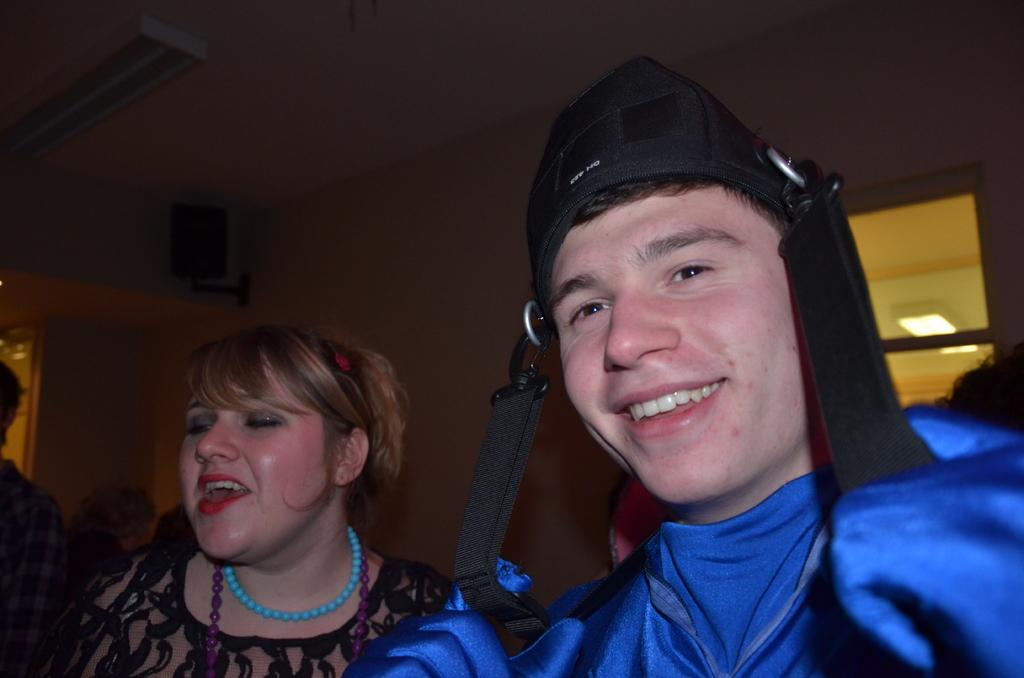Who are the people in the image? There is a man and a woman in the image. What is the man doing in the image? The man is smiling in the image. What can be seen in the background of the image? There is a wall in the background of the image. What type of debt is the man discussing with the woman in the image? There is no indication in the image that the man and woman are discussing debt or any other financial matter. 